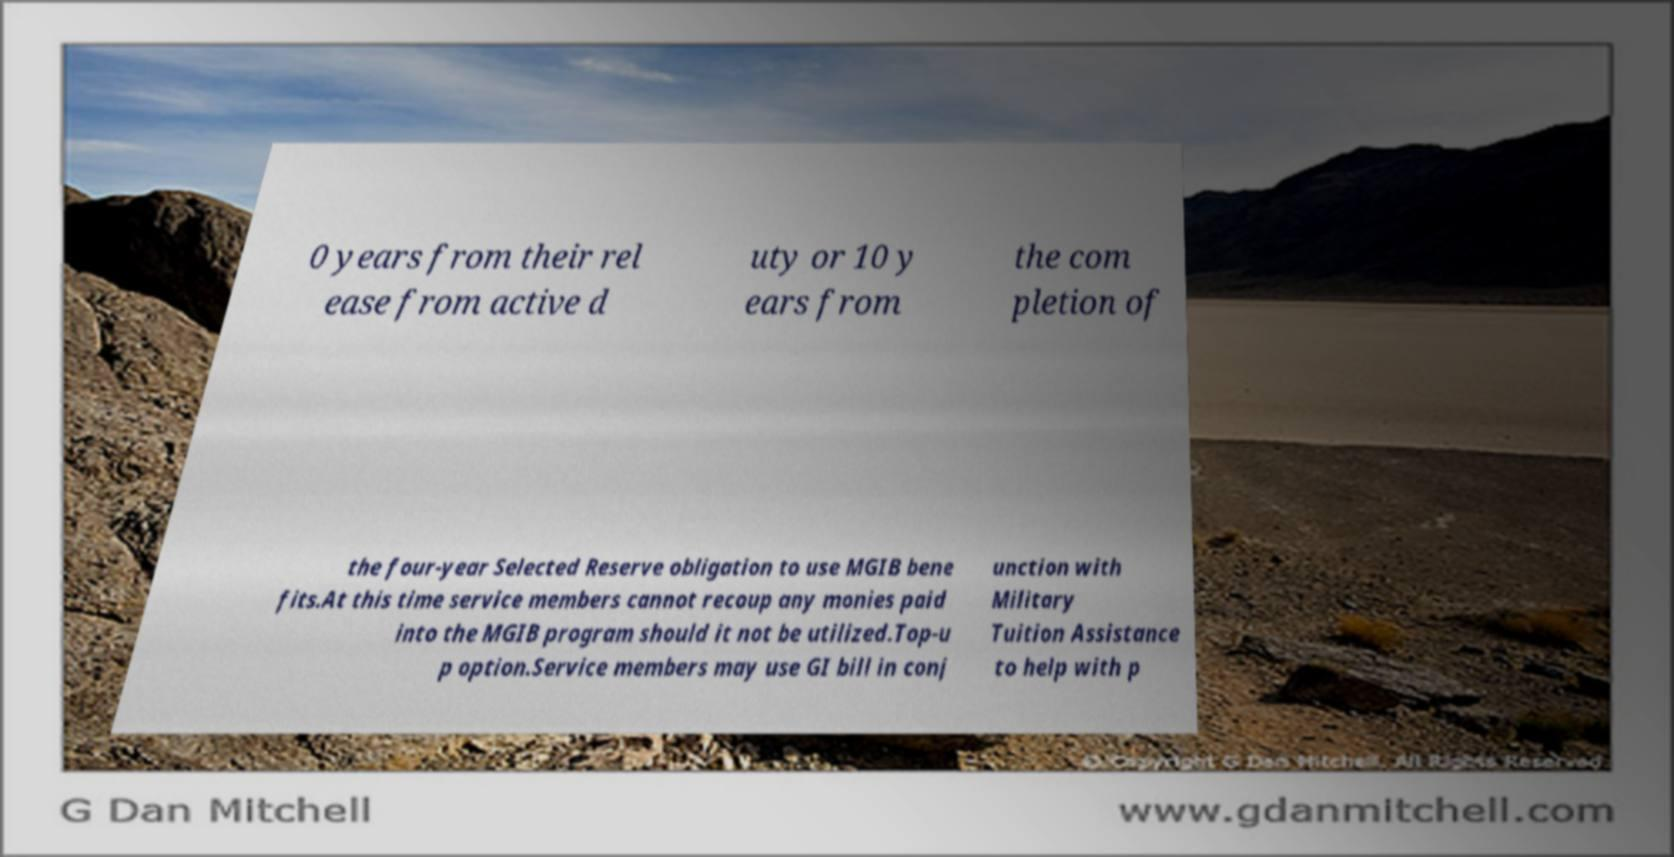For documentation purposes, I need the text within this image transcribed. Could you provide that? 0 years from their rel ease from active d uty or 10 y ears from the com pletion of the four-year Selected Reserve obligation to use MGIB bene fits.At this time service members cannot recoup any monies paid into the MGIB program should it not be utilized.Top-u p option.Service members may use GI bill in conj unction with Military Tuition Assistance to help with p 